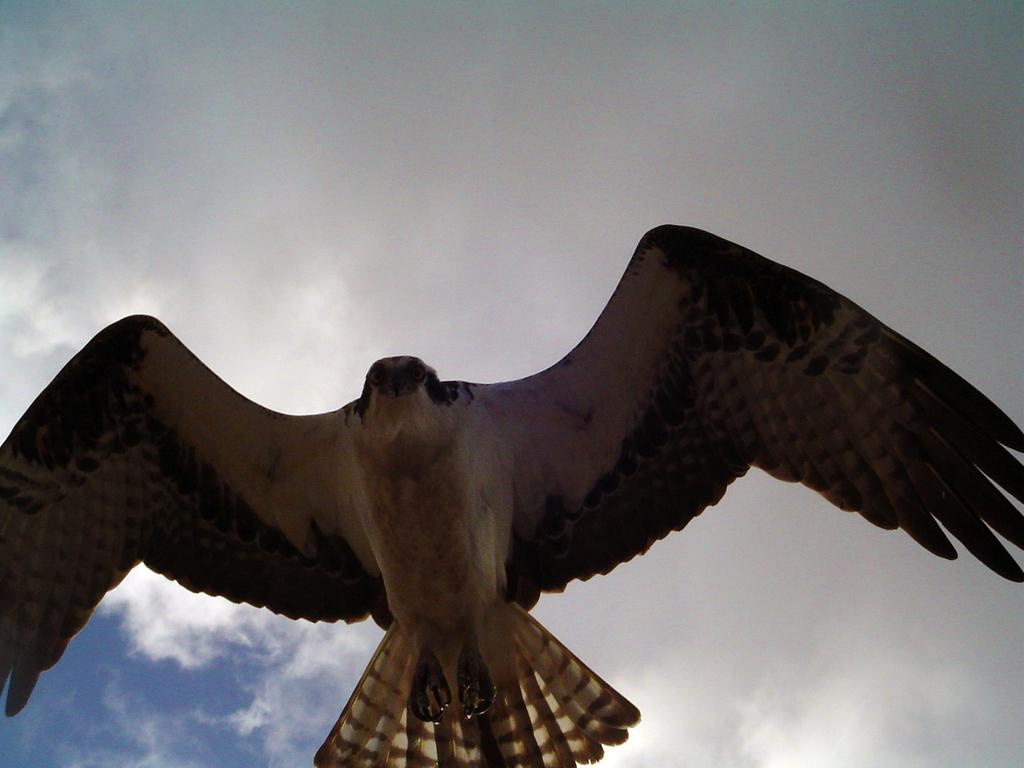What animal can be seen in the image? There is an eagle in the image. What part of the natural environment is visible in the image? The sky is visible in the image. How many cherries are being sliced by the knife in the image? There is no knife or cherries present in the image. 